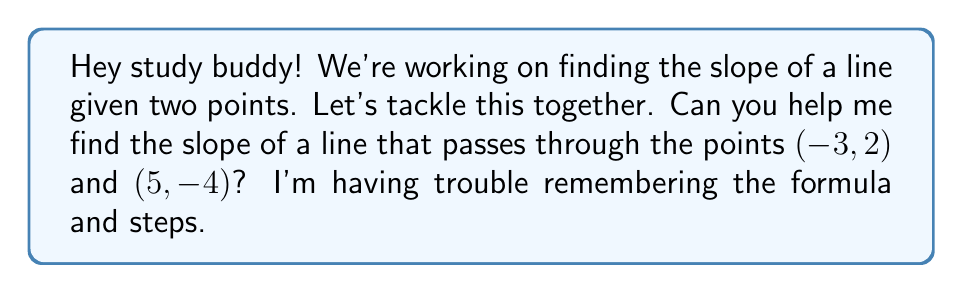Provide a solution to this math problem. Sure thing! Let's work through this step-by-step:

1) The slope formula is:

   $$m = \frac{y_2 - y_1}{x_2 - x_1}$$

   where $(x_1, y_1)$ and $(x_2, y_2)$ are two points on the line.

2) We have the points $(-3, 2)$ and $(5, -4)$. Let's assign them:
   $(x_1, y_1) = (-3, 2)$
   $(x_2, y_2) = (5, -4)$

3) Now, let's plug these into our formula:

   $$m = \frac{y_2 - y_1}{x_2 - x_1} = \frac{-4 - 2}{5 - (-3)}$$

4) Simplify the numerator and denominator:

   $$m = \frac{-6}{5 + 3} = \frac{-6}{8}$$

5) Reduce the fraction:

   $$m = -\frac{3}{4}$$

And that's our slope! Remember, the slope represents the change in y over the change in x, or "rise over run". In this case, for every 4 units we move to the right, we go down 3 units.
Answer: $m = -\frac{3}{4}$ 